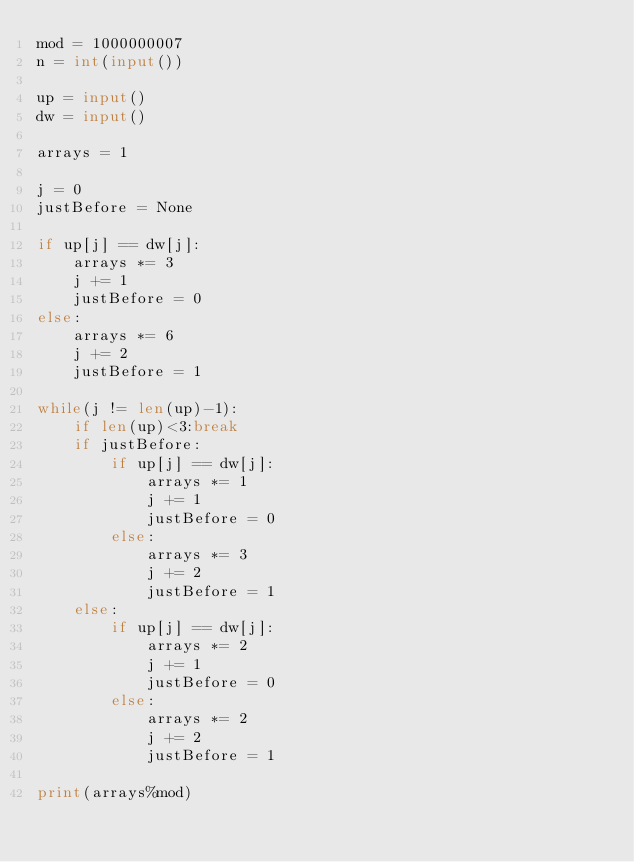Convert code to text. <code><loc_0><loc_0><loc_500><loc_500><_Python_>mod = 1000000007
n = int(input())

up = input()
dw = input()

arrays = 1

j = 0
justBefore = None

if up[j] == dw[j]:
    arrays *= 3
    j += 1
    justBefore = 0
else:
    arrays *= 6
    j += 2
    justBefore = 1

while(j != len(up)-1):
    if len(up)<3:break
    if justBefore:
        if up[j] == dw[j]:
            arrays *= 1
            j += 1
            justBefore = 0
        else:
            arrays *= 3
            j += 2
            justBefore = 1
    else:
        if up[j] == dw[j]:
            arrays *= 2
            j += 1
            justBefore = 0
        else:
            arrays *= 2
            j += 2
            justBefore = 1
            
print(arrays%mod)</code> 